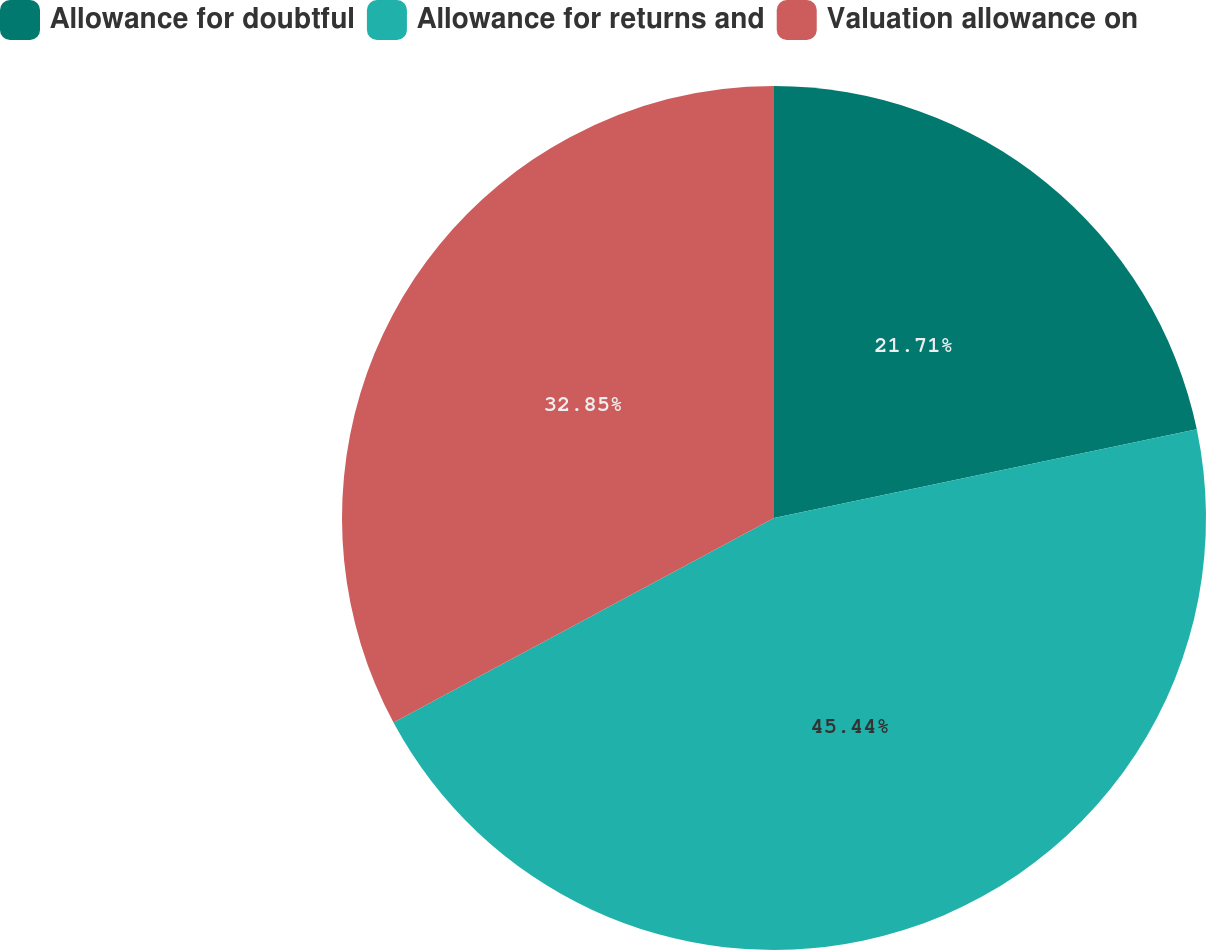Convert chart. <chart><loc_0><loc_0><loc_500><loc_500><pie_chart><fcel>Allowance for doubtful<fcel>Allowance for returns and<fcel>Valuation allowance on<nl><fcel>21.71%<fcel>45.44%<fcel>32.85%<nl></chart> 